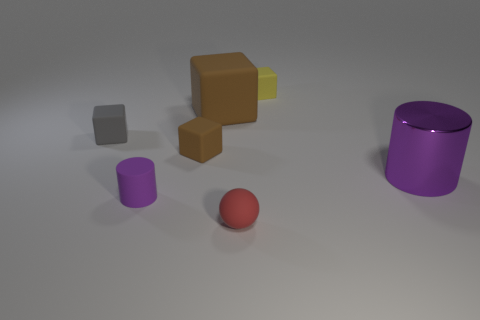Is there any other thing that is made of the same material as the big cylinder?
Offer a very short reply. No. What is the small purple thing made of?
Your answer should be compact. Rubber. There is a tiny yellow rubber thing; does it have the same shape as the large thing behind the big purple shiny thing?
Offer a terse response. Yes. What material is the small cube right of the red object that is right of the small block that is left of the tiny matte cylinder made of?
Give a very brief answer. Rubber. What number of gray blocks are there?
Give a very brief answer. 1. How many purple objects are either tiny cylinders or tiny matte things?
Your response must be concise. 1. How many other objects are there of the same shape as the large purple thing?
Offer a terse response. 1. There is a cylinder to the right of the sphere; does it have the same color as the cylinder that is left of the ball?
Keep it short and to the point. Yes. What number of tiny things are either purple cylinders or matte balls?
Give a very brief answer. 2. There is another yellow matte thing that is the same shape as the big rubber object; what size is it?
Provide a short and direct response. Small. 